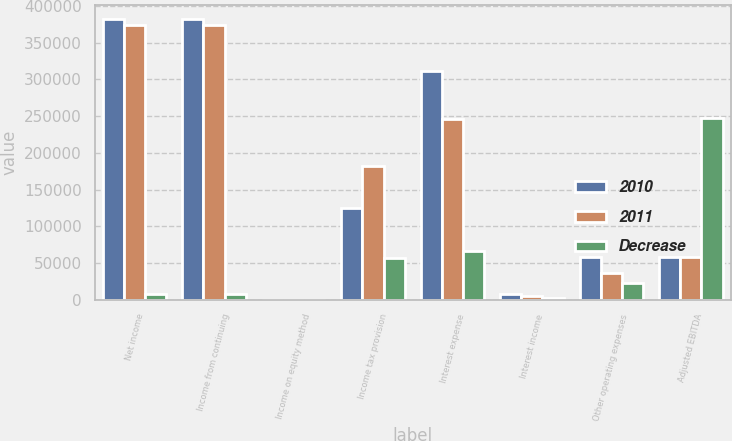Convert chart to OTSL. <chart><loc_0><loc_0><loc_500><loc_500><stacked_bar_chart><ecel><fcel>Net income<fcel>Income from continuing<fcel>Income on equity method<fcel>Income tax provision<fcel>Interest expense<fcel>Interest income<fcel>Other operating expenses<fcel>Adjusted EBITDA<nl><fcel>2010<fcel>381840<fcel>381840<fcel>25<fcel>125080<fcel>311854<fcel>7378<fcel>58103<fcel>57756<nl><fcel>2011<fcel>373606<fcel>373576<fcel>40<fcel>182489<fcel>246018<fcel>5024<fcel>35876<fcel>57756<nl><fcel>Decrease<fcel>8234<fcel>8264<fcel>15<fcel>57409<fcel>65836<fcel>2354<fcel>22227<fcel>247656<nl></chart> 